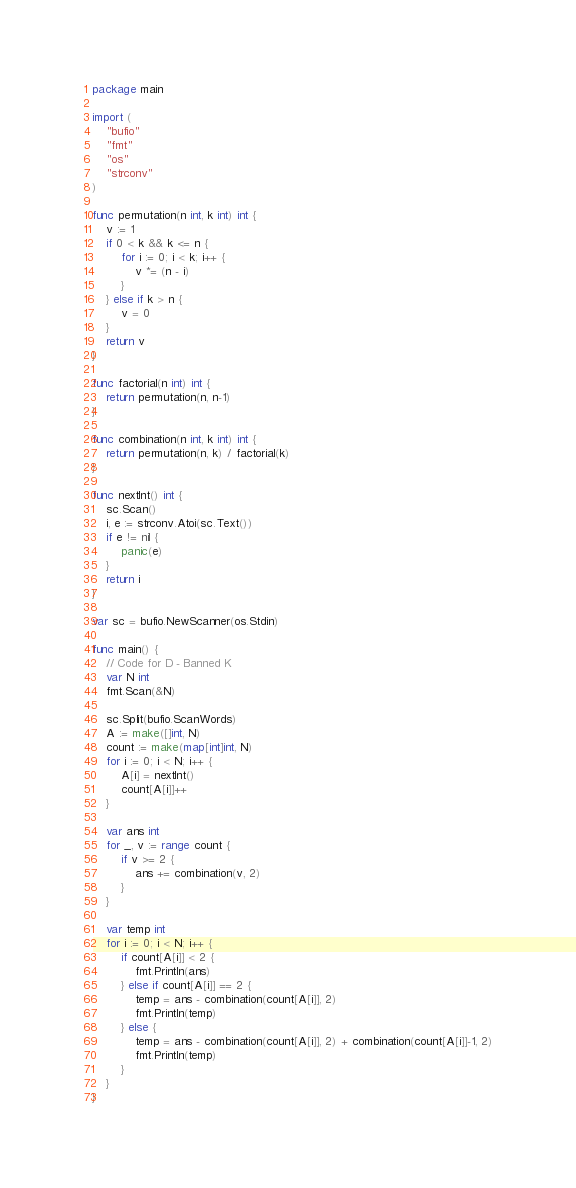<code> <loc_0><loc_0><loc_500><loc_500><_Go_>package main

import (
	"bufio"
	"fmt"
	"os"
	"strconv"
)

func permutation(n int, k int) int {
	v := 1
	if 0 < k && k <= n {
		for i := 0; i < k; i++ {
			v *= (n - i)
		}
	} else if k > n {
		v = 0
	}
	return v
}

func factorial(n int) int {
	return permutation(n, n-1)
}

func combination(n int, k int) int {
	return permutation(n, k) / factorial(k)
}

func nextInt() int {
	sc.Scan()
	i, e := strconv.Atoi(sc.Text())
	if e != nil {
		panic(e)
	}
	return i
}

var sc = bufio.NewScanner(os.Stdin)

func main() {
	// Code for D - Banned K
	var N int
	fmt.Scan(&N)

	sc.Split(bufio.ScanWords)
	A := make([]int, N)
	count := make(map[int]int, N)
	for i := 0; i < N; i++ {
		A[i] = nextInt()
		count[A[i]]++
	}

	var ans int
	for _, v := range count {
		if v >= 2 {
			ans += combination(v, 2)
		}
	}

	var temp int
	for i := 0; i < N; i++ {
		if count[A[i]] < 2 {
			fmt.Println(ans)
		} else if count[A[i]] == 2 {
			temp = ans - combination(count[A[i]], 2)
			fmt.Println(temp)
		} else {
			temp = ans - combination(count[A[i]], 2) + combination(count[A[i]]-1, 2)
			fmt.Println(temp)
		}
	}
}
</code> 